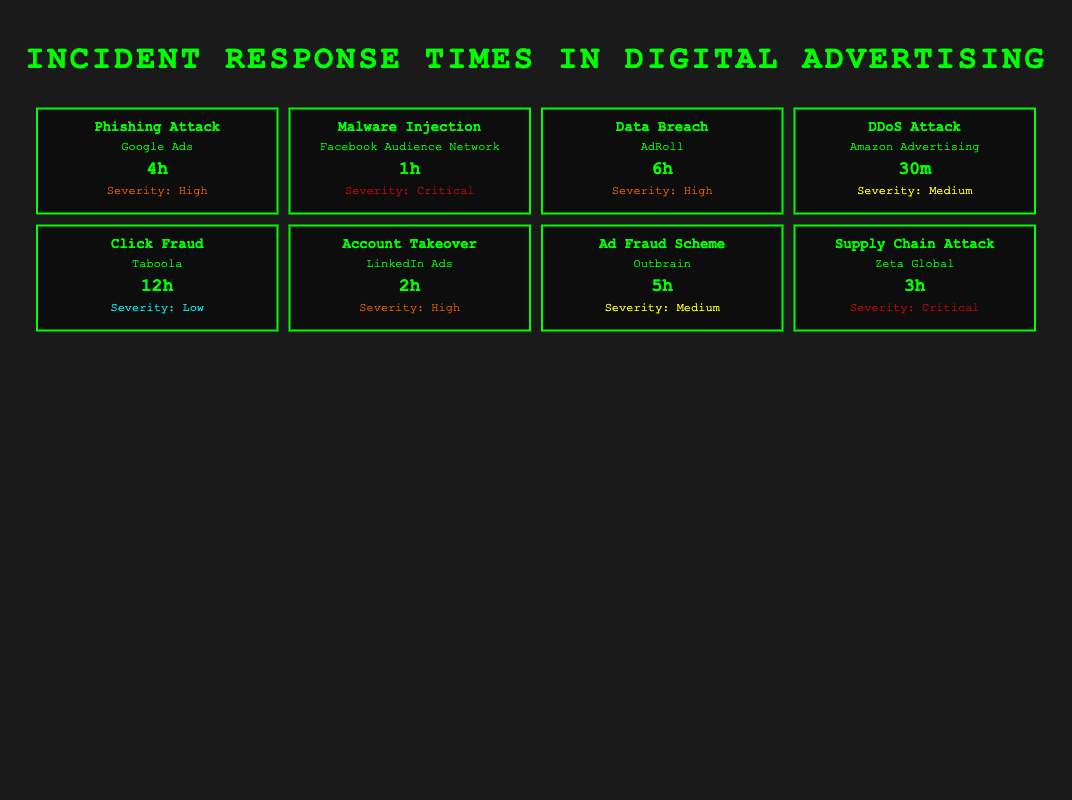What is the response time for a Malware Injection incident at Facebook Audience Network? The response time is specified directly under the "Response Time" column for the "Malware Injection" entry associated with Facebook Audience Network, which is 1 hour.
Answer: 1 hour Which incident type has the shortest response time? I need to check all the incident types listed and compare their response times. The DDoS Attack entry has the shortest response time of 30 minutes.
Answer: 30 minutes What are the prevention measures for the Phishing Attack at Google Ads? Under the "Prevention Measures" section for the Phishing Attack related to Google Ads, the measures listed are user education and two-factor authentication.
Answer: User education, Two-factor authentication Is the impact of a Click Fraud incident severe? The impact listed for Click Fraud at Taboola is "Increased advertising costs and decreased ROI," which does not suggest a severe impact compared to other incidents like data breaches or malware injections.
Answer: No What is the average response time for incidents with "High" severity? The incidents with High severity are Phishing Attack (4 hours), Data Breach (6 hours), and Account Takeover (2 hours). Summing these gives 4 + 6 + 2 = 12 hours. There are 3 incidents, so the average response time is 12/3 = 4 hours.
Answer: 4 hours Which incident has the highest severity and what is its response time? From the table, the incidents labeled as Critical severity are mentioned for Malware Injection and Supply Chain Attack. However, the one with the highest severity is the Malware Injection with a response time of 1 hour.
Answer: 1 hour For which incident type is the Time to Contain the least? The DDoS Attack has a Time to Contain of 15 minutes, which is the least compared to other incidents.
Answer: 15 minutes Does AdRoll have a Data Breach incident in their response time table? Yes, there is an entry for a Data Breach listed under the company AdRoll, confirming its presence in the data.
Answer: Yes 